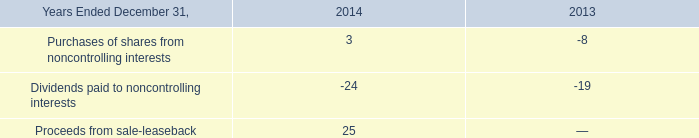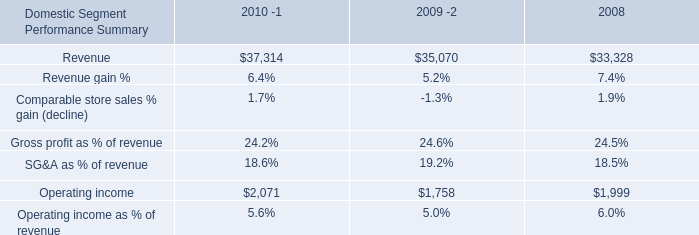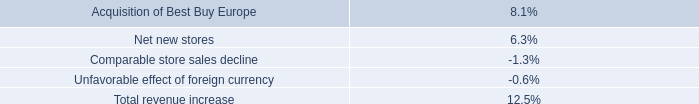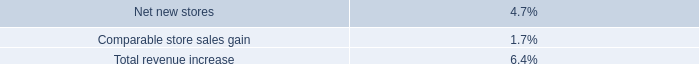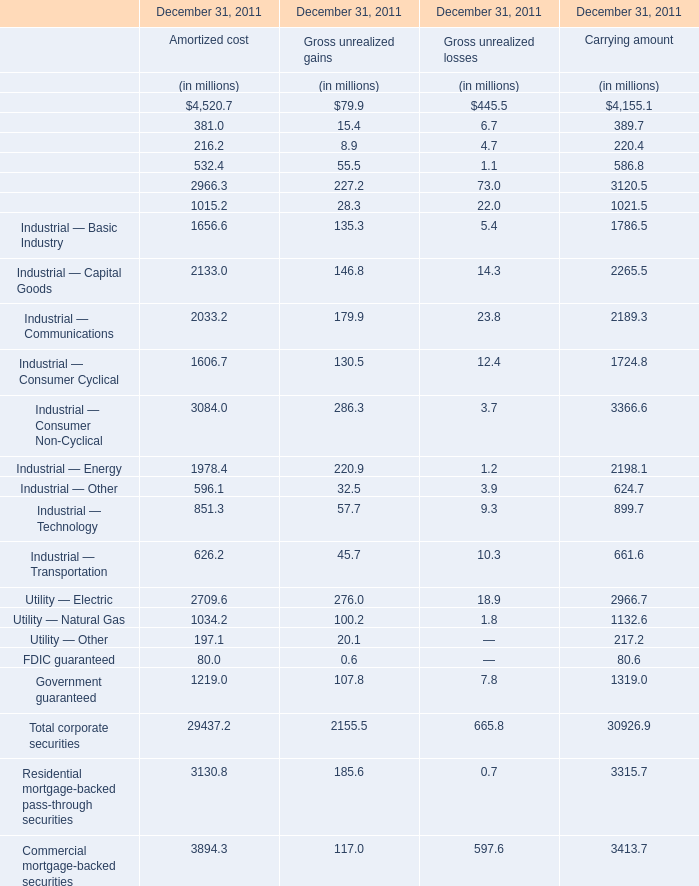What is the sum of the Utility — Other for total in the years where Finance — Banking greater than 70 for Gross unrealized gains ? (in million) 
Computations: ((197.1 + 20.1) + 217.2)
Answer: 434.4. 